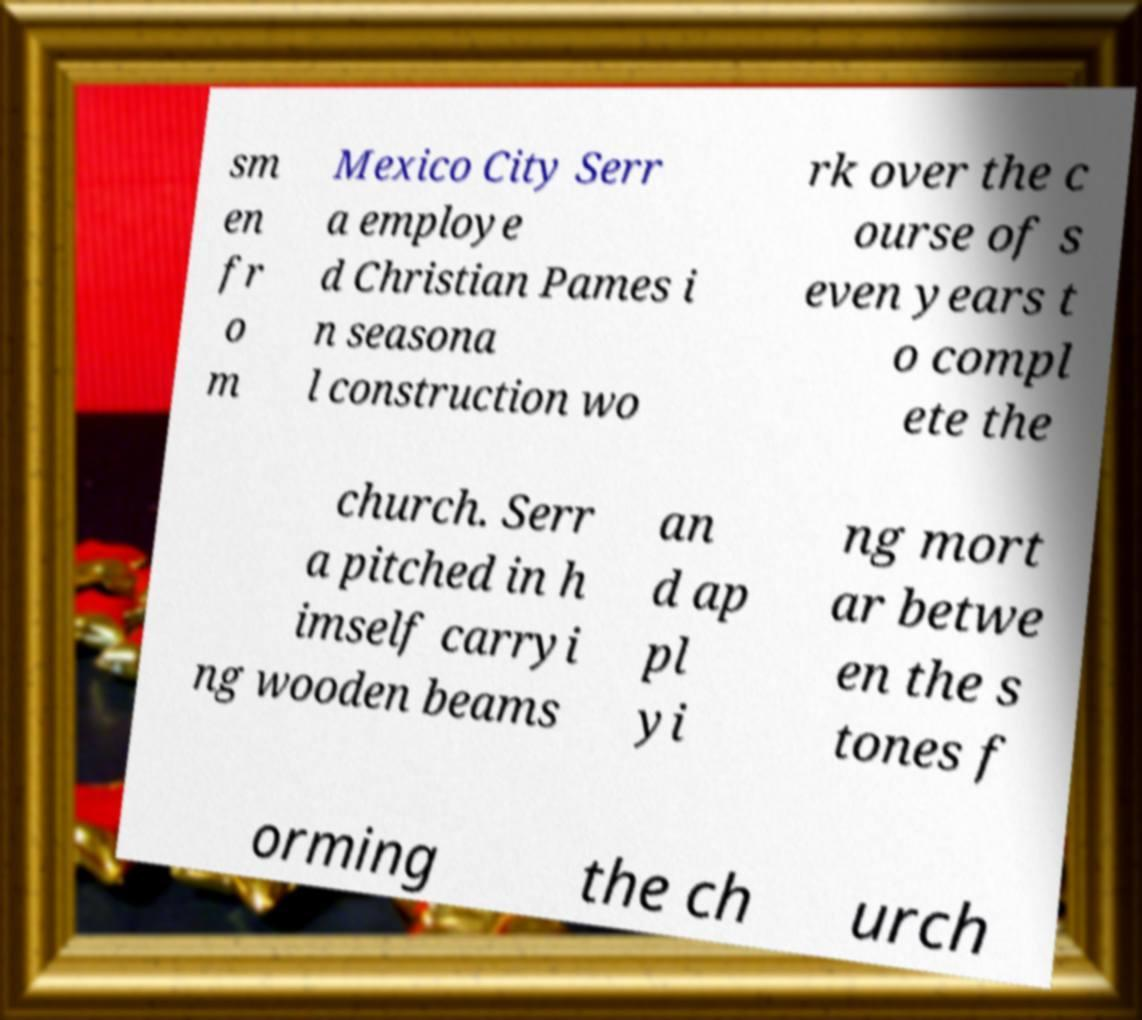Can you accurately transcribe the text from the provided image for me? sm en fr o m Mexico City Serr a employe d Christian Pames i n seasona l construction wo rk over the c ourse of s even years t o compl ete the church. Serr a pitched in h imself carryi ng wooden beams an d ap pl yi ng mort ar betwe en the s tones f orming the ch urch 